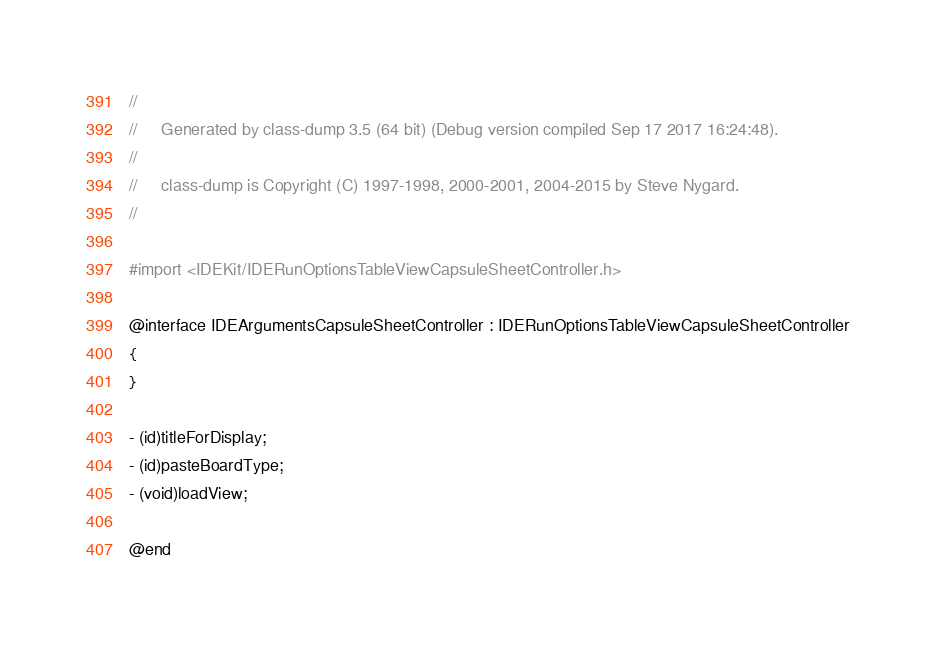Convert code to text. <code><loc_0><loc_0><loc_500><loc_500><_C_>//
//     Generated by class-dump 3.5 (64 bit) (Debug version compiled Sep 17 2017 16:24:48).
//
//     class-dump is Copyright (C) 1997-1998, 2000-2001, 2004-2015 by Steve Nygard.
//

#import <IDEKit/IDERunOptionsTableViewCapsuleSheetController.h>

@interface IDEArgumentsCapsuleSheetController : IDERunOptionsTableViewCapsuleSheetController
{
}

- (id)titleForDisplay;
- (id)pasteBoardType;
- (void)loadView;

@end

</code> 